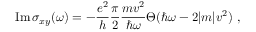<formula> <loc_0><loc_0><loc_500><loc_500>I m \, \sigma _ { x y } ( \omega ) = - \frac { e ^ { 2 } } { h } \frac { \pi } { 2 } \frac { m v ^ { 2 } } { \hbar { \omega } } \Theta ( \hbar { \omega } - 2 | m | v ^ { 2 } ) \ ,</formula> 